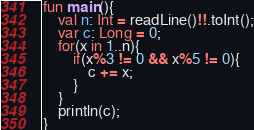Convert code to text. <code><loc_0><loc_0><loc_500><loc_500><_Kotlin_>fun main(){
    val n: Int = readLine()!!.toInt();
    var c: Long = 0;
    for(x in 1..n){
        if(x%3 != 0 && x%5 != 0){
            c += x;
        }
    }
    println(c);
}</code> 